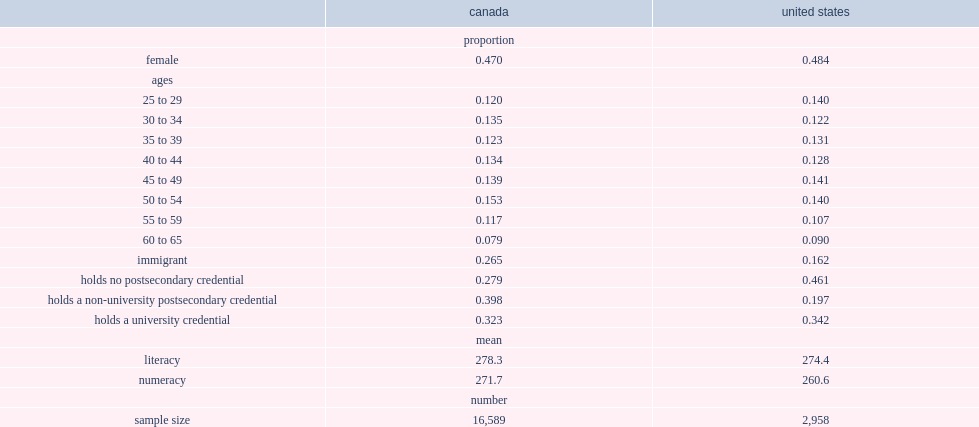Which country workers in are more likely to be women, the united states or canadian counterparts? United states. How many percent of canadian workers are immigrants? 0.265. How many percent of american workers are immigrants? 0.162. What was he mean literacy test score in canada, where workers scored on average? 278.3. What was he mean literacy test score in the united states, where workers scored on average? 274.4. Help me parse the entirety of this table. {'header': ['', 'canada', 'united states'], 'rows': [['', 'proportion', ''], ['female', '0.470', '0.484'], ['ages', '', ''], ['25 to 29', '0.120', '0.140'], ['30 to 34', '0.135', '0.122'], ['35 to 39', '0.123', '0.131'], ['40 to 44', '0.134', '0.128'], ['45 to 49', '0.139', '0.141'], ['50 to 54', '0.153', '0.140'], ['55 to 59', '0.117', '0.107'], ['60 to 65', '0.079', '0.090'], ['immigrant', '0.265', '0.162'], ['holds no postsecondary credential', '0.279', '0.461'], ['holds a non-university postsecondary credential', '0.398', '0.197'], ['holds a university credential', '0.323', '0.342'], ['', 'mean', ''], ['literacy', '278.3', '274.4'], ['numeracy', '271.7', '260.6'], ['', 'number', ''], ['sample size', '16,589', '2,958']]} 